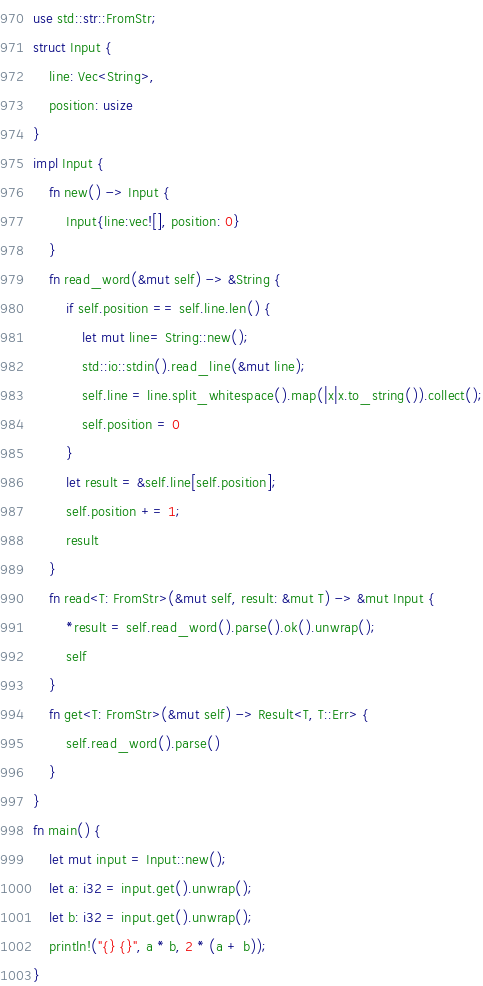<code> <loc_0><loc_0><loc_500><loc_500><_Rust_>use std::str::FromStr;
struct Input {
    line: Vec<String>,
    position: usize
}
impl Input {
    fn new() -> Input {
        Input{line:vec![], position: 0}
    }
    fn read_word(&mut self) -> &String {
        if self.position == self.line.len() {
            let mut line= String::new();
            std::io::stdin().read_line(&mut line);
            self.line = line.split_whitespace().map(|x|x.to_string()).collect();
            self.position = 0
        }
        let result = &self.line[self.position];
        self.position += 1;
        result
    }
    fn read<T: FromStr>(&mut self, result: &mut T) -> &mut Input {
        *result = self.read_word().parse().ok().unwrap();
        self
    }
    fn get<T: FromStr>(&mut self) -> Result<T, T::Err> {
        self.read_word().parse()
    }
}
fn main() {
    let mut input = Input::new();
    let a: i32 = input.get().unwrap();
    let b: i32 = input.get().unwrap();
    println!("{} {}", a * b, 2 * (a + b));
}
</code> 